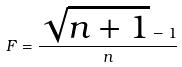Convert formula to latex. <formula><loc_0><loc_0><loc_500><loc_500>F = \frac { \sqrt { n + 1 } - 1 } { n }</formula> 